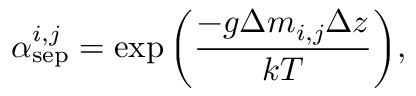Convert formula to latex. <formula><loc_0><loc_0><loc_500><loc_500>\alpha _ { s e p } ^ { i , j } = \exp \left ( \frac { - g \Delta m _ { i , j } \Delta z } { k T } \right ) ,</formula> 